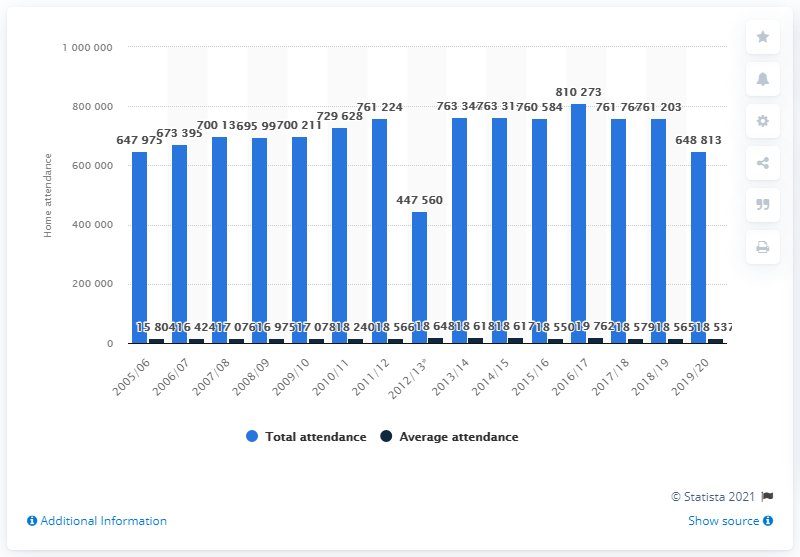Outline some significant characteristics in this image. During the season of 2005/2006, the Pittsburgh Penguins franchise was in operation. 